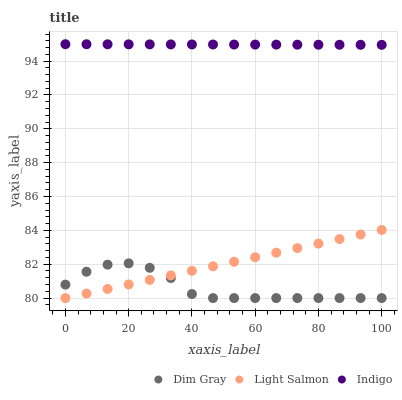Does Dim Gray have the minimum area under the curve?
Answer yes or no. Yes. Does Indigo have the maximum area under the curve?
Answer yes or no. Yes. Does Indigo have the minimum area under the curve?
Answer yes or no. No. Does Dim Gray have the maximum area under the curve?
Answer yes or no. No. Is Indigo the smoothest?
Answer yes or no. Yes. Is Dim Gray the roughest?
Answer yes or no. Yes. Is Dim Gray the smoothest?
Answer yes or no. No. Is Indigo the roughest?
Answer yes or no. No. Does Light Salmon have the lowest value?
Answer yes or no. Yes. Does Indigo have the lowest value?
Answer yes or no. No. Does Indigo have the highest value?
Answer yes or no. Yes. Does Dim Gray have the highest value?
Answer yes or no. No. Is Light Salmon less than Indigo?
Answer yes or no. Yes. Is Indigo greater than Light Salmon?
Answer yes or no. Yes. Does Light Salmon intersect Dim Gray?
Answer yes or no. Yes. Is Light Salmon less than Dim Gray?
Answer yes or no. No. Is Light Salmon greater than Dim Gray?
Answer yes or no. No. Does Light Salmon intersect Indigo?
Answer yes or no. No. 